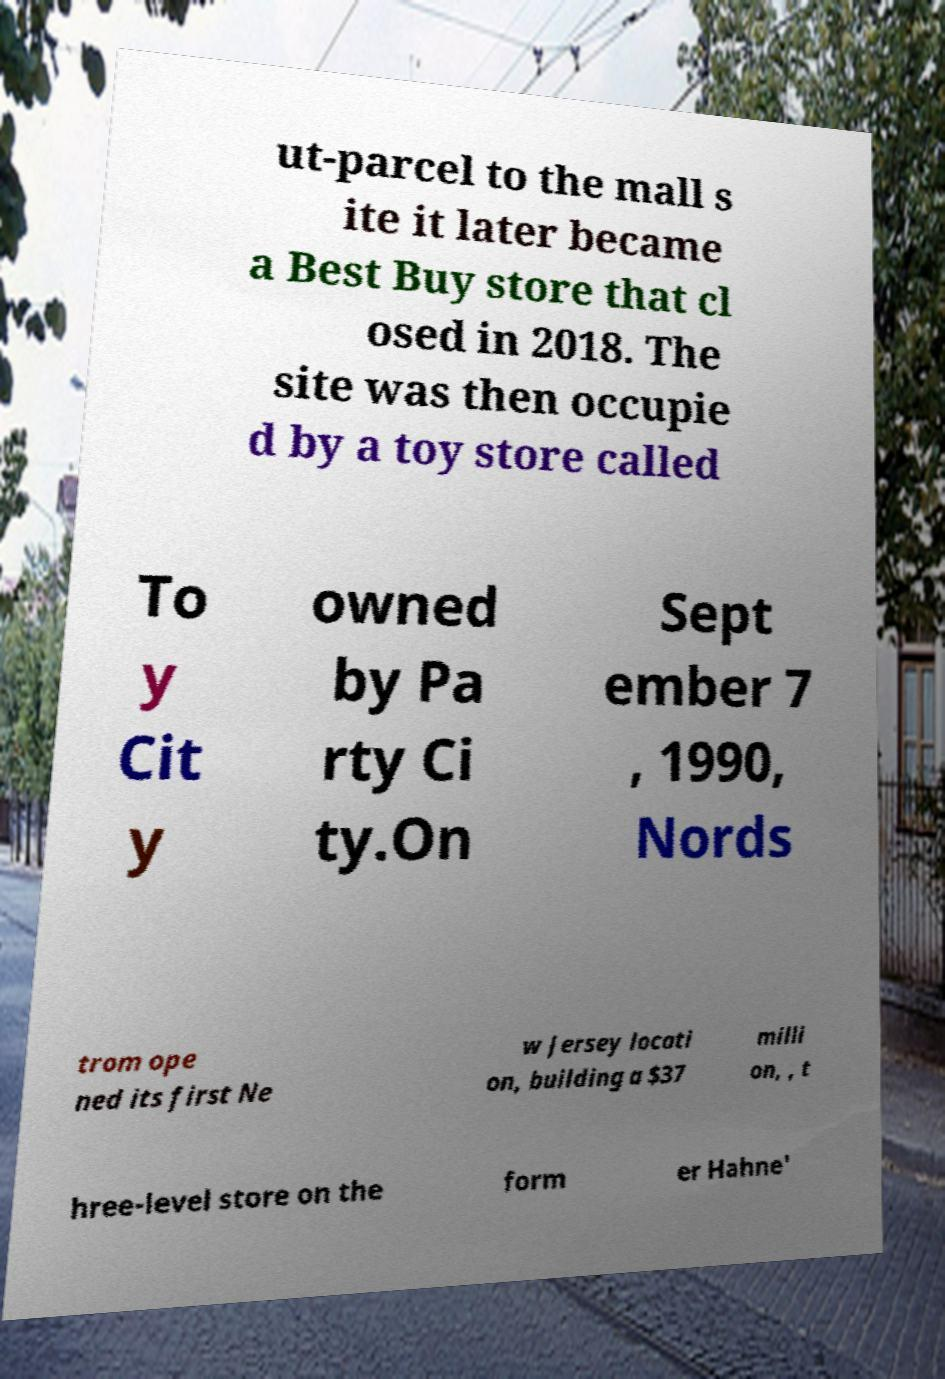Please read and relay the text visible in this image. What does it say? ut-parcel to the mall s ite it later became a Best Buy store that cl osed in 2018. The site was then occupie d by a toy store called To y Cit y owned by Pa rty Ci ty.On Sept ember 7 , 1990, Nords trom ope ned its first Ne w Jersey locati on, building a $37 milli on, , t hree-level store on the form er Hahne' 